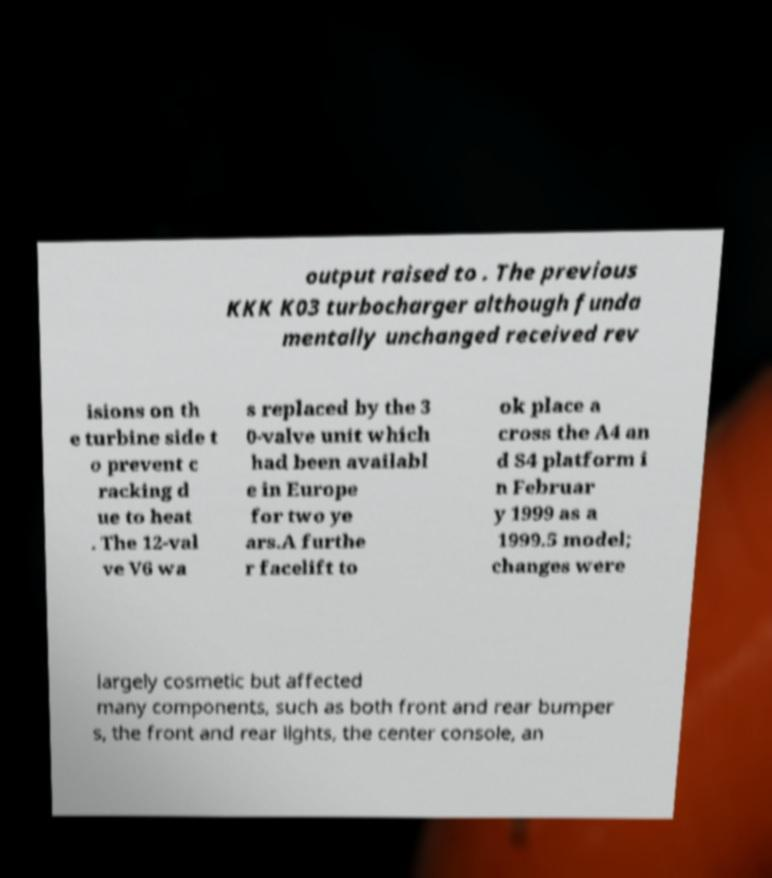Please identify and transcribe the text found in this image. output raised to . The previous KKK K03 turbocharger although funda mentally unchanged received rev isions on th e turbine side t o prevent c racking d ue to heat . The 12-val ve V6 wa s replaced by the 3 0-valve unit which had been availabl e in Europe for two ye ars.A furthe r facelift to ok place a cross the A4 an d S4 platform i n Februar y 1999 as a 1999.5 model; changes were largely cosmetic but affected many components, such as both front and rear bumper s, the front and rear lights, the center console, an 